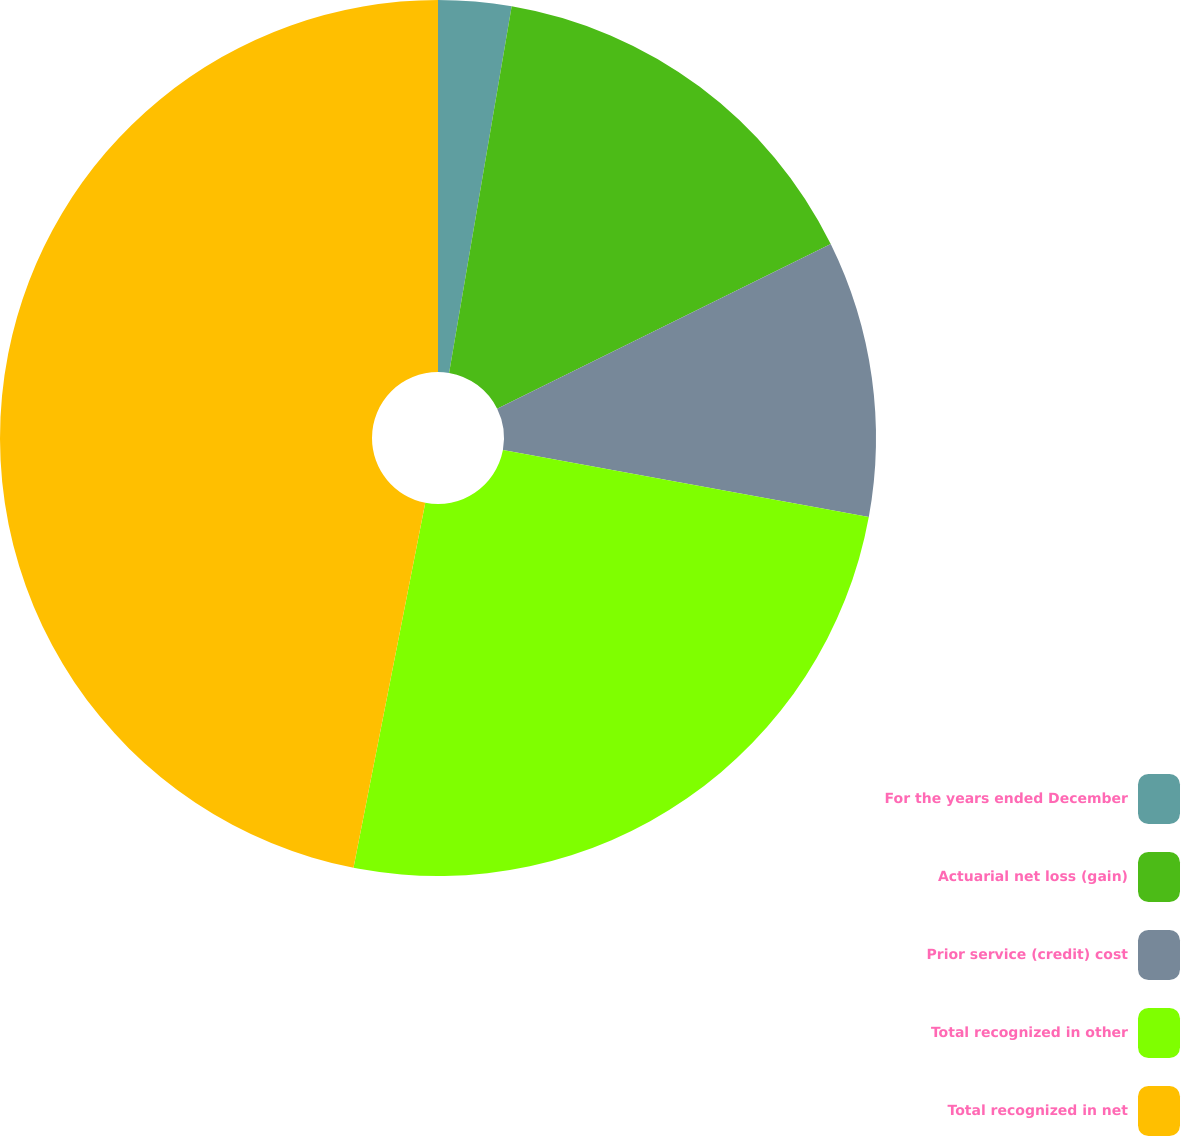Convert chart to OTSL. <chart><loc_0><loc_0><loc_500><loc_500><pie_chart><fcel>For the years ended December<fcel>Actuarial net loss (gain)<fcel>Prior service (credit) cost<fcel>Total recognized in other<fcel>Total recognized in net<nl><fcel>2.69%<fcel>15.01%<fcel>10.19%<fcel>25.2%<fcel>46.91%<nl></chart> 